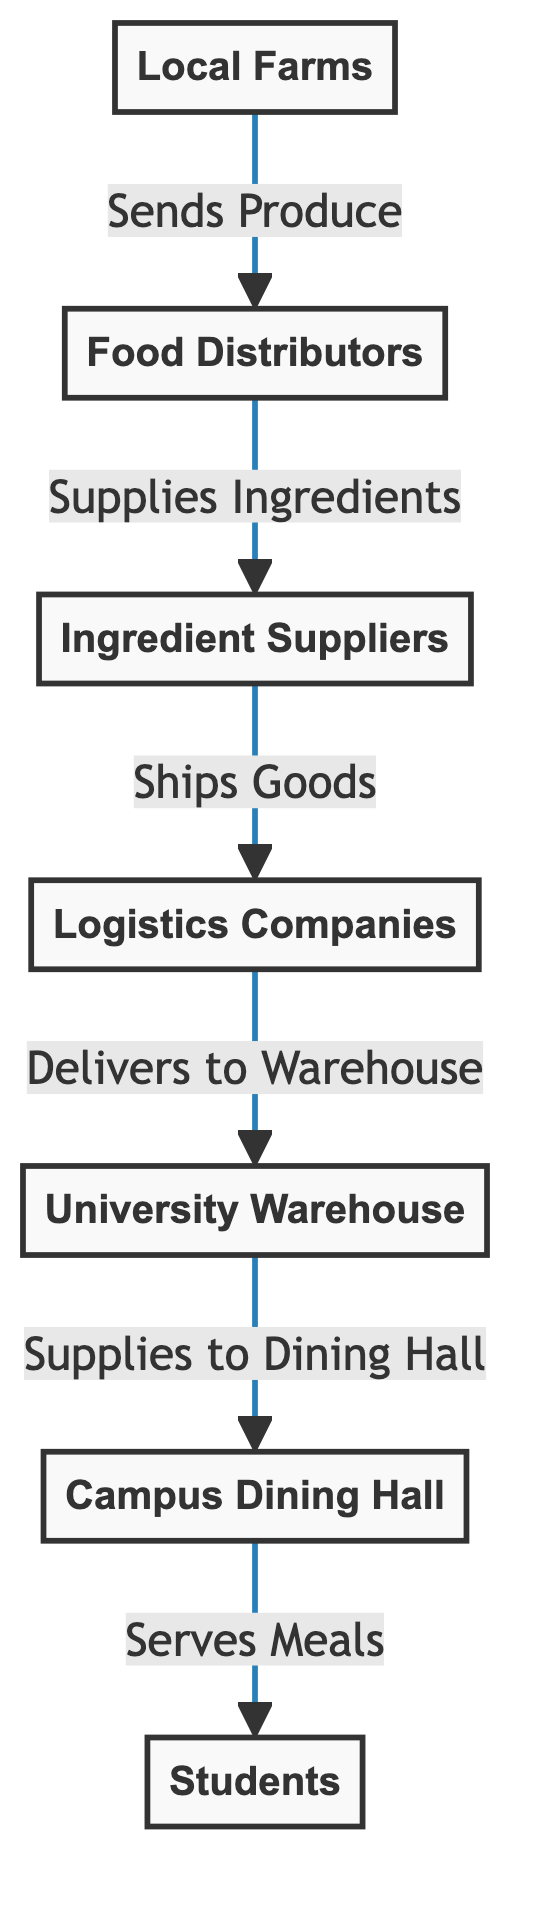What is the first entity in the food supply network? The first entity in the food supply network is "Local Farms," as it is the starting point indicated in the flowchart.
Answer: Local Farms How many nodes are there in the food supply network? The nodes in the diagram include Local Farms, Food Distributors, Ingredient Suppliers, Logistics Companies, University Warehouse, Campus Dining Hall, and Students, totaling seven nodes.
Answer: Seven What role do distributors play in the network? Distributors play the role of supplying ingredients, as indicated by the arrow labeled "Supplies Ingredients" pointing from distributors to suppliers.
Answer: Supplies Ingredients Which entity is connected to the University Warehouse? The entity connected to the University Warehouse is "Logistics Companies," as shown by the arrow leading from logistics to warehouse.
Answer: Logistics Companies What is the final destination of the food supply network? The final destination of the network is "Students," as they receive meals served from the Campus Dining Hall.
Answer: Students How many connections lead from campuses dining hall? There is one connection leading from Campus Dining Hall, which serves meals to students.
Answer: One What does the arrow labeled "Ships Goods" indicate? The arrow labeled "Ships Goods" indicates that ingredient suppliers are responsible for shipping goods to logistics companies.
Answer: Shipping goods What’s the relationship between ingredient suppliers and logistics companies? The relationship is that ingredient suppliers ship goods to logistics companies, as shown by the directed arrow between these two nodes.
Answer: Ships Goods Which node does the University Warehouse supply to? The University Warehouse supplies to the "Campus Dining Hall," as indicated by the arrow showing the flow from warehouse to campus dining.
Answer: Campus Dining Hall 